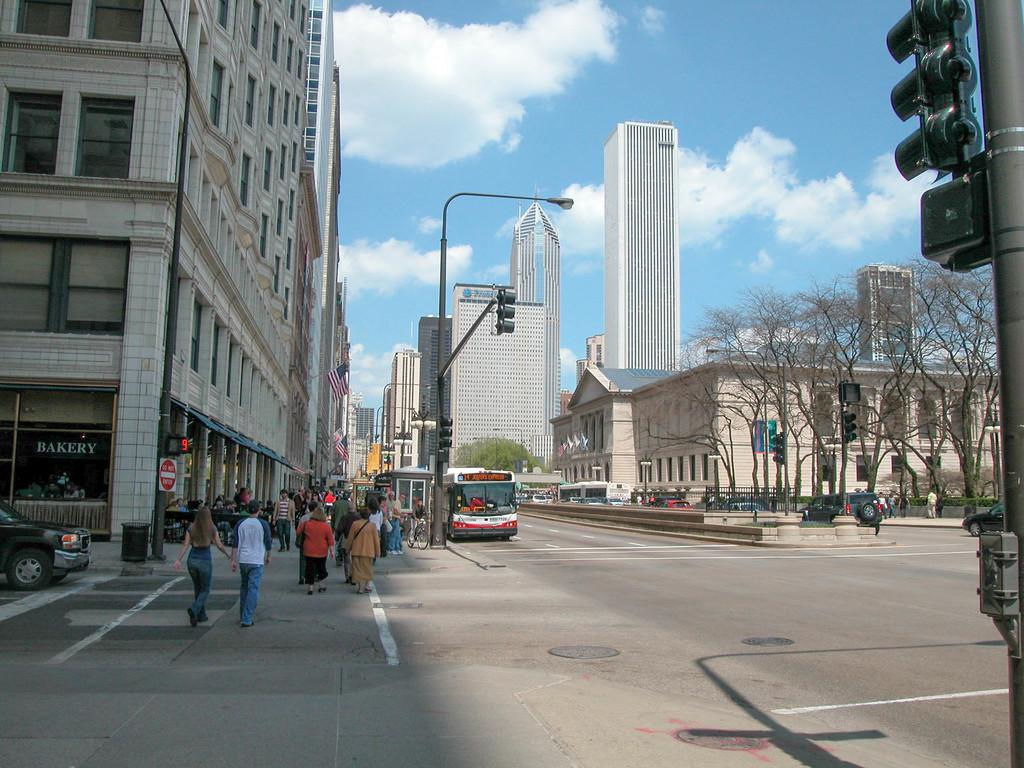What are the people in the image doing? The people in the image are walking together. What type of buildings can be seen in the image? There are skyscrapers in the image. What type of lighting is present in the image? There are streetlights in the image. What mode of transportation is visible in the image? A bus is standing in the image. What type of vegetation is near the road in the image? There is a group of trees beside a road in the image. What song is being sung by the trees in the image? The trees in the image are not singing a song; they are a part of the natural landscape. 